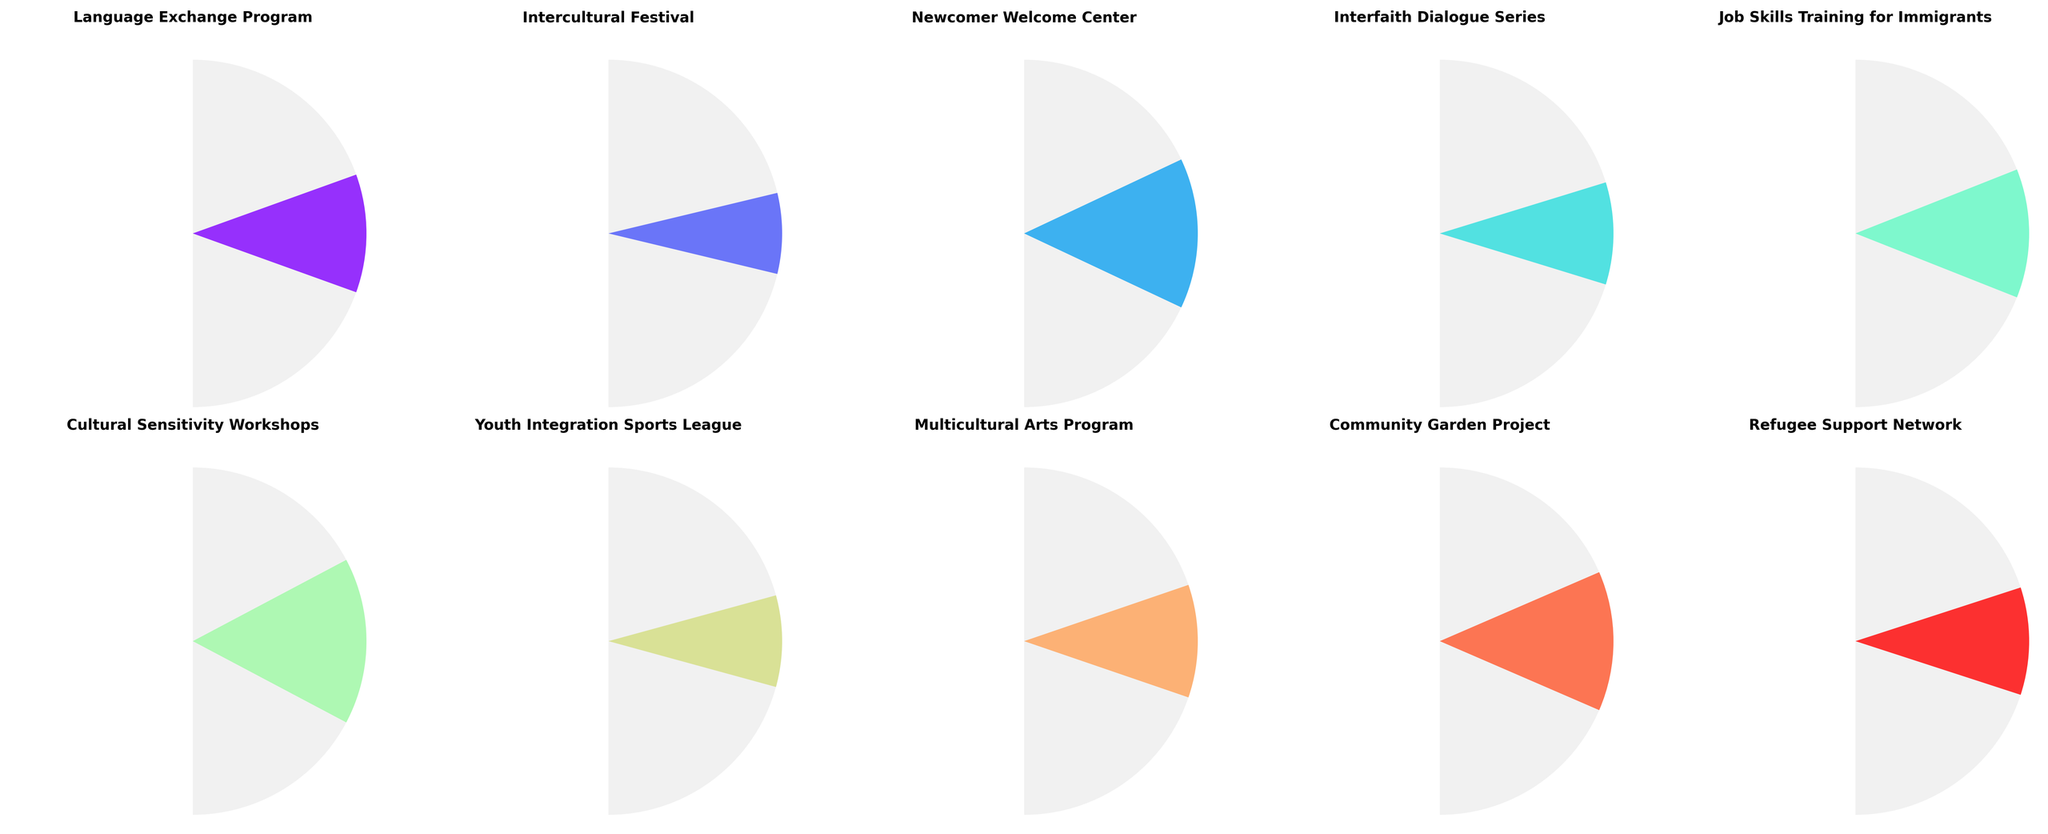What is the satisfaction level with the Intercultural Festival? The Intercultural Festival gauge shows a satisfaction level of 85%.
Answer: 85% Which program has the lowest satisfaction level? The Cultural Sensitivity Workshops gauge shows the lowest satisfaction level at 69%.
Answer: Cultural Sensitivity Workshops What is the difference in satisfaction levels between the Youth Integration Sports League and the Refugee Support Network? The Youth Integration Sports League has a satisfaction level of 83%, and the Refugee Support Network has a satisfaction level of 80%. The difference is 83% - 80% = 3%.
Answer: 3% How many programs have a satisfaction level of 80% or higher? The programs with satisfaction levels of 80% or higher are the Intercultural Festival (85%), Youth Integration Sports League (83%), Interfaith Dialogue Series (81%), Refugee Support Network (80%), and Multicultural Arts Program (79%). So there are 5 programs in total.
Answer: 5 What is the average satisfaction level across all the programs? The satisfaction levels of all programs are [78, 85, 72, 81, 76, 69, 83, 79, 74, 80]. The sum is 78 + 85 + 72 + 81 + 76 + 69 + 83 + 79 + 74 + 80 = 777. The average is 777/10 = 77.7%.
Answer: 77.7% What is the satisfaction level of the Multicultural Arts Program? The Multicultural Arts Program gauge shows a satisfaction level of 79%.
Answer: 79% Which two programs have the closest satisfaction levels? The satisfaction levels of the Community Garden Project and the Newcomer Welcome Center are 74% and 72%, respectively. The difference is 74% - 72% = 2%, which is the smallest difference among all pairs of programs.
Answer: Community Garden Project and Newcomer Welcome Center Is the satisfaction level of the Job Skills Training for Immigrants higher or lower than the overall average satisfaction level? The overall average satisfaction level is 77.7%. The Job Skills Training for Immigrants has a satisfaction level of 76%, which is lower than the overall average.
Answer: Lower Which program has a higher satisfaction level: Language Exchange Program or Cultural Sensitivity Workshops? The Language Exchange Program has a satisfaction level of 78%, while the Cultural Sensitivity Workshops have a satisfaction level of 69%. Thus, the Language Exchange Program has a higher satisfaction level.
Answer: Language Exchange Program What is the median satisfaction level of the listed programs? When the satisfaction levels are sorted ([69, 72, 74, 76, 78, 79, 80, 81, 83, 85]), the median (the middle value in the sorted list) is the 5th and 6th values averaged: (78 + 79)/2 = 78.5%.
Answer: 78.5% 